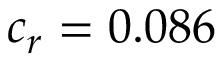Convert formula to latex. <formula><loc_0><loc_0><loc_500><loc_500>c _ { r } = 0 . 0 8 6</formula> 